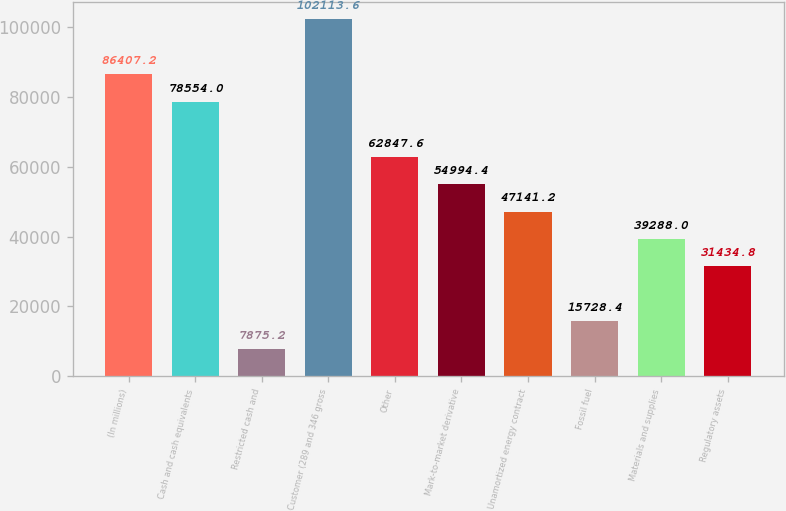Convert chart to OTSL. <chart><loc_0><loc_0><loc_500><loc_500><bar_chart><fcel>(In millions)<fcel>Cash and cash equivalents<fcel>Restricted cash and<fcel>Customer (289 and 346 gross<fcel>Other<fcel>Mark-to-market derivative<fcel>Unamortized energy contract<fcel>Fossil fuel<fcel>Materials and supplies<fcel>Regulatory assets<nl><fcel>86407.2<fcel>78554<fcel>7875.2<fcel>102114<fcel>62847.6<fcel>54994.4<fcel>47141.2<fcel>15728.4<fcel>39288<fcel>31434.8<nl></chart> 